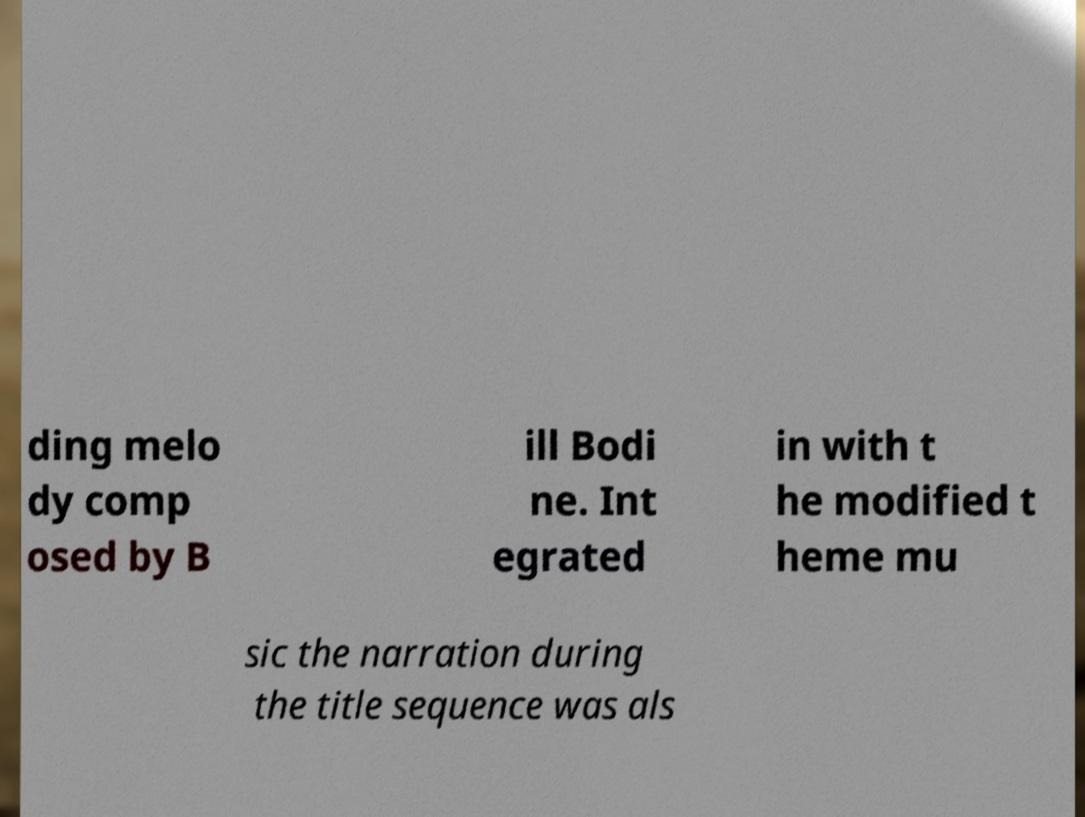Could you assist in decoding the text presented in this image and type it out clearly? ding melo dy comp osed by B ill Bodi ne. Int egrated in with t he modified t heme mu sic the narration during the title sequence was als 